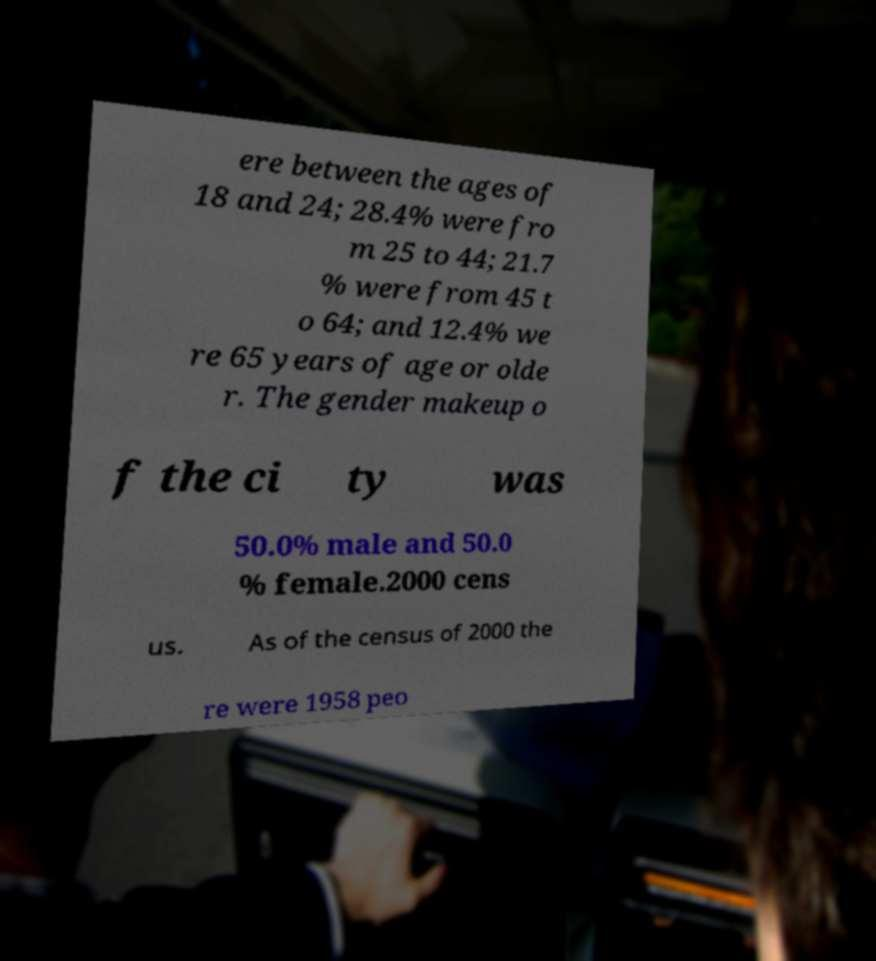I need the written content from this picture converted into text. Can you do that? ere between the ages of 18 and 24; 28.4% were fro m 25 to 44; 21.7 % were from 45 t o 64; and 12.4% we re 65 years of age or olde r. The gender makeup o f the ci ty was 50.0% male and 50.0 % female.2000 cens us. As of the census of 2000 the re were 1958 peo 